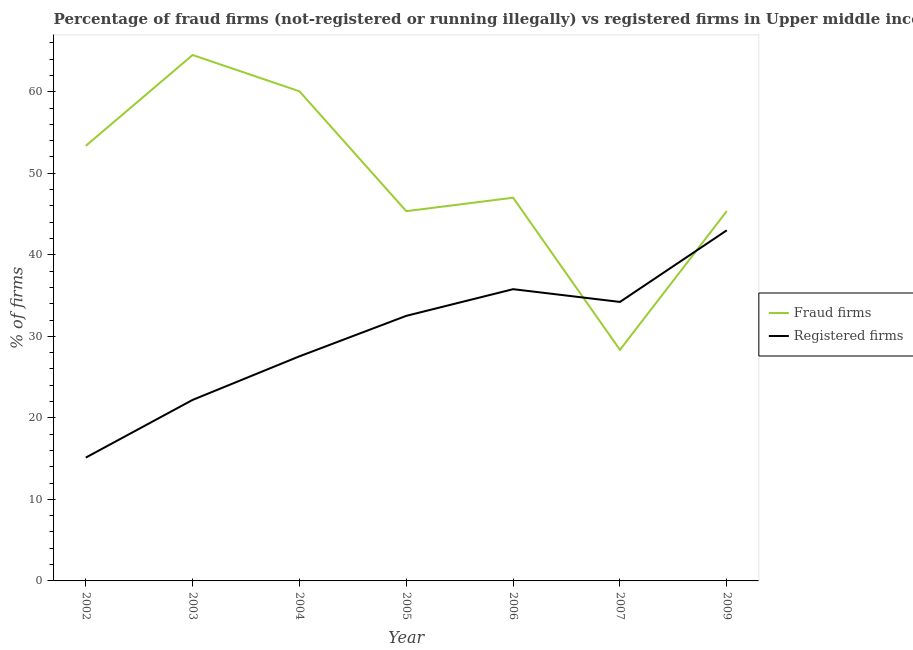How many different coloured lines are there?
Give a very brief answer. 2. Does the line corresponding to percentage of registered firms intersect with the line corresponding to percentage of fraud firms?
Keep it short and to the point. Yes. What is the percentage of fraud firms in 2002?
Make the answer very short. 53.35. Across all years, what is the minimum percentage of registered firms?
Make the answer very short. 15.12. In which year was the percentage of fraud firms maximum?
Your answer should be compact. 2003. What is the total percentage of registered firms in the graph?
Provide a short and direct response. 210.37. What is the difference between the percentage of registered firms in 2002 and that in 2007?
Ensure brevity in your answer.  -19.09. What is the difference between the percentage of registered firms in 2005 and the percentage of fraud firms in 2006?
Ensure brevity in your answer.  -14.49. What is the average percentage of registered firms per year?
Provide a succinct answer. 30.05. In the year 2003, what is the difference between the percentage of fraud firms and percentage of registered firms?
Make the answer very short. 42.3. In how many years, is the percentage of registered firms greater than 58 %?
Provide a succinct answer. 0. What is the ratio of the percentage of registered firms in 2004 to that in 2005?
Provide a short and direct response. 0.85. Is the percentage of registered firms in 2007 less than that in 2009?
Provide a short and direct response. Yes. Is the difference between the percentage of registered firms in 2003 and 2009 greater than the difference between the percentage of fraud firms in 2003 and 2009?
Your answer should be very brief. No. What is the difference between the highest and the second highest percentage of registered firms?
Ensure brevity in your answer.  7.22. What is the difference between the highest and the lowest percentage of registered firms?
Your answer should be compact. 27.88. In how many years, is the percentage of registered firms greater than the average percentage of registered firms taken over all years?
Ensure brevity in your answer.  4. Is the sum of the percentage of fraud firms in 2004 and 2005 greater than the maximum percentage of registered firms across all years?
Keep it short and to the point. Yes. Does the percentage of registered firms monotonically increase over the years?
Your answer should be very brief. No. How many years are there in the graph?
Make the answer very short. 7. Are the values on the major ticks of Y-axis written in scientific E-notation?
Offer a very short reply. No. Does the graph contain grids?
Keep it short and to the point. No. Where does the legend appear in the graph?
Your response must be concise. Center right. How many legend labels are there?
Make the answer very short. 2. How are the legend labels stacked?
Ensure brevity in your answer.  Vertical. What is the title of the graph?
Give a very brief answer. Percentage of fraud firms (not-registered or running illegally) vs registered firms in Upper middle income. Does "Register a property" appear as one of the legend labels in the graph?
Your response must be concise. No. What is the label or title of the X-axis?
Provide a succinct answer. Year. What is the label or title of the Y-axis?
Provide a short and direct response. % of firms. What is the % of firms in Fraud firms in 2002?
Offer a terse response. 53.35. What is the % of firms in Registered firms in 2002?
Make the answer very short. 15.12. What is the % of firms in Fraud firms in 2003?
Offer a very short reply. 64.5. What is the % of firms of Fraud firms in 2004?
Your response must be concise. 60.05. What is the % of firms in Registered firms in 2004?
Provide a short and direct response. 27.55. What is the % of firms of Fraud firms in 2005?
Your answer should be very brief. 45.35. What is the % of firms of Registered firms in 2005?
Your answer should be compact. 32.51. What is the % of firms of Fraud firms in 2006?
Keep it short and to the point. 47. What is the % of firms of Registered firms in 2006?
Keep it short and to the point. 35.78. What is the % of firms in Fraud firms in 2007?
Offer a terse response. 28.34. What is the % of firms of Registered firms in 2007?
Ensure brevity in your answer.  34.22. What is the % of firms of Fraud firms in 2009?
Give a very brief answer. 45.35. Across all years, what is the maximum % of firms in Fraud firms?
Make the answer very short. 64.5. Across all years, what is the maximum % of firms in Registered firms?
Make the answer very short. 43. Across all years, what is the minimum % of firms in Fraud firms?
Offer a very short reply. 28.34. Across all years, what is the minimum % of firms of Registered firms?
Your response must be concise. 15.12. What is the total % of firms of Fraud firms in the graph?
Offer a very short reply. 343.94. What is the total % of firms in Registered firms in the graph?
Keep it short and to the point. 210.37. What is the difference between the % of firms in Fraud firms in 2002 and that in 2003?
Your answer should be compact. -11.15. What is the difference between the % of firms of Registered firms in 2002 and that in 2003?
Provide a succinct answer. -7.08. What is the difference between the % of firms of Fraud firms in 2002 and that in 2004?
Your answer should be very brief. -6.7. What is the difference between the % of firms in Registered firms in 2002 and that in 2004?
Provide a short and direct response. -12.42. What is the difference between the % of firms in Fraud firms in 2002 and that in 2005?
Your response must be concise. 8.01. What is the difference between the % of firms in Registered firms in 2002 and that in 2005?
Your answer should be compact. -17.39. What is the difference between the % of firms in Fraud firms in 2002 and that in 2006?
Make the answer very short. 6.36. What is the difference between the % of firms in Registered firms in 2002 and that in 2006?
Your response must be concise. -20.66. What is the difference between the % of firms of Fraud firms in 2002 and that in 2007?
Ensure brevity in your answer.  25.01. What is the difference between the % of firms in Registered firms in 2002 and that in 2007?
Offer a terse response. -19.09. What is the difference between the % of firms of Fraud firms in 2002 and that in 2009?
Make the answer very short. 8. What is the difference between the % of firms in Registered firms in 2002 and that in 2009?
Ensure brevity in your answer.  -27.88. What is the difference between the % of firms in Fraud firms in 2003 and that in 2004?
Provide a short and direct response. 4.45. What is the difference between the % of firms of Registered firms in 2003 and that in 2004?
Provide a succinct answer. -5.35. What is the difference between the % of firms in Fraud firms in 2003 and that in 2005?
Provide a short and direct response. 19.15. What is the difference between the % of firms of Registered firms in 2003 and that in 2005?
Your response must be concise. -10.31. What is the difference between the % of firms in Fraud firms in 2003 and that in 2006?
Offer a terse response. 17.5. What is the difference between the % of firms in Registered firms in 2003 and that in 2006?
Your answer should be very brief. -13.58. What is the difference between the % of firms in Fraud firms in 2003 and that in 2007?
Provide a short and direct response. 36.16. What is the difference between the % of firms of Registered firms in 2003 and that in 2007?
Ensure brevity in your answer.  -12.02. What is the difference between the % of firms in Fraud firms in 2003 and that in 2009?
Your response must be concise. 19.15. What is the difference between the % of firms in Registered firms in 2003 and that in 2009?
Keep it short and to the point. -20.8. What is the difference between the % of firms in Fraud firms in 2004 and that in 2005?
Make the answer very short. 14.7. What is the difference between the % of firms in Registered firms in 2004 and that in 2005?
Give a very brief answer. -4.96. What is the difference between the % of firms of Fraud firms in 2004 and that in 2006?
Give a very brief answer. 13.05. What is the difference between the % of firms of Registered firms in 2004 and that in 2006?
Ensure brevity in your answer.  -8.23. What is the difference between the % of firms of Fraud firms in 2004 and that in 2007?
Give a very brief answer. 31.71. What is the difference between the % of firms in Registered firms in 2004 and that in 2007?
Ensure brevity in your answer.  -6.67. What is the difference between the % of firms in Fraud firms in 2004 and that in 2009?
Your answer should be very brief. 14.7. What is the difference between the % of firms of Registered firms in 2004 and that in 2009?
Make the answer very short. -15.45. What is the difference between the % of firms of Fraud firms in 2005 and that in 2006?
Your answer should be very brief. -1.65. What is the difference between the % of firms in Registered firms in 2005 and that in 2006?
Your answer should be compact. -3.27. What is the difference between the % of firms of Fraud firms in 2005 and that in 2007?
Your response must be concise. 17.01. What is the difference between the % of firms in Registered firms in 2005 and that in 2007?
Your response must be concise. -1.71. What is the difference between the % of firms in Fraud firms in 2005 and that in 2009?
Provide a succinct answer. -0.01. What is the difference between the % of firms of Registered firms in 2005 and that in 2009?
Provide a succinct answer. -10.49. What is the difference between the % of firms of Fraud firms in 2006 and that in 2007?
Your answer should be very brief. 18.66. What is the difference between the % of firms of Registered firms in 2006 and that in 2007?
Your answer should be very brief. 1.56. What is the difference between the % of firms of Fraud firms in 2006 and that in 2009?
Make the answer very short. 1.64. What is the difference between the % of firms in Registered firms in 2006 and that in 2009?
Offer a terse response. -7.22. What is the difference between the % of firms in Fraud firms in 2007 and that in 2009?
Your response must be concise. -17.01. What is the difference between the % of firms of Registered firms in 2007 and that in 2009?
Keep it short and to the point. -8.78. What is the difference between the % of firms in Fraud firms in 2002 and the % of firms in Registered firms in 2003?
Your answer should be compact. 31.15. What is the difference between the % of firms of Fraud firms in 2002 and the % of firms of Registered firms in 2004?
Keep it short and to the point. 25.81. What is the difference between the % of firms in Fraud firms in 2002 and the % of firms in Registered firms in 2005?
Your answer should be compact. 20.84. What is the difference between the % of firms of Fraud firms in 2002 and the % of firms of Registered firms in 2006?
Offer a terse response. 17.57. What is the difference between the % of firms in Fraud firms in 2002 and the % of firms in Registered firms in 2007?
Your response must be concise. 19.14. What is the difference between the % of firms of Fraud firms in 2002 and the % of firms of Registered firms in 2009?
Provide a succinct answer. 10.35. What is the difference between the % of firms in Fraud firms in 2003 and the % of firms in Registered firms in 2004?
Provide a short and direct response. 36.95. What is the difference between the % of firms in Fraud firms in 2003 and the % of firms in Registered firms in 2005?
Your answer should be compact. 31.99. What is the difference between the % of firms in Fraud firms in 2003 and the % of firms in Registered firms in 2006?
Provide a succinct answer. 28.72. What is the difference between the % of firms of Fraud firms in 2003 and the % of firms of Registered firms in 2007?
Your answer should be very brief. 30.28. What is the difference between the % of firms of Fraud firms in 2003 and the % of firms of Registered firms in 2009?
Offer a terse response. 21.5. What is the difference between the % of firms in Fraud firms in 2004 and the % of firms in Registered firms in 2005?
Your answer should be compact. 27.54. What is the difference between the % of firms of Fraud firms in 2004 and the % of firms of Registered firms in 2006?
Give a very brief answer. 24.27. What is the difference between the % of firms of Fraud firms in 2004 and the % of firms of Registered firms in 2007?
Keep it short and to the point. 25.83. What is the difference between the % of firms in Fraud firms in 2004 and the % of firms in Registered firms in 2009?
Ensure brevity in your answer.  17.05. What is the difference between the % of firms in Fraud firms in 2005 and the % of firms in Registered firms in 2006?
Your answer should be compact. 9.57. What is the difference between the % of firms of Fraud firms in 2005 and the % of firms of Registered firms in 2007?
Your answer should be very brief. 11.13. What is the difference between the % of firms of Fraud firms in 2005 and the % of firms of Registered firms in 2009?
Keep it short and to the point. 2.35. What is the difference between the % of firms of Fraud firms in 2006 and the % of firms of Registered firms in 2007?
Your answer should be compact. 12.78. What is the difference between the % of firms in Fraud firms in 2006 and the % of firms in Registered firms in 2009?
Keep it short and to the point. 4. What is the difference between the % of firms in Fraud firms in 2007 and the % of firms in Registered firms in 2009?
Make the answer very short. -14.66. What is the average % of firms in Fraud firms per year?
Provide a short and direct response. 49.13. What is the average % of firms in Registered firms per year?
Provide a short and direct response. 30.05. In the year 2002, what is the difference between the % of firms of Fraud firms and % of firms of Registered firms?
Provide a succinct answer. 38.23. In the year 2003, what is the difference between the % of firms in Fraud firms and % of firms in Registered firms?
Ensure brevity in your answer.  42.3. In the year 2004, what is the difference between the % of firms in Fraud firms and % of firms in Registered firms?
Make the answer very short. 32.5. In the year 2005, what is the difference between the % of firms of Fraud firms and % of firms of Registered firms?
Provide a succinct answer. 12.84. In the year 2006, what is the difference between the % of firms in Fraud firms and % of firms in Registered firms?
Provide a short and direct response. 11.22. In the year 2007, what is the difference between the % of firms of Fraud firms and % of firms of Registered firms?
Your response must be concise. -5.88. In the year 2009, what is the difference between the % of firms in Fraud firms and % of firms in Registered firms?
Keep it short and to the point. 2.35. What is the ratio of the % of firms of Fraud firms in 2002 to that in 2003?
Make the answer very short. 0.83. What is the ratio of the % of firms of Registered firms in 2002 to that in 2003?
Offer a very short reply. 0.68. What is the ratio of the % of firms in Fraud firms in 2002 to that in 2004?
Keep it short and to the point. 0.89. What is the ratio of the % of firms of Registered firms in 2002 to that in 2004?
Your response must be concise. 0.55. What is the ratio of the % of firms in Fraud firms in 2002 to that in 2005?
Make the answer very short. 1.18. What is the ratio of the % of firms of Registered firms in 2002 to that in 2005?
Offer a very short reply. 0.47. What is the ratio of the % of firms in Fraud firms in 2002 to that in 2006?
Give a very brief answer. 1.14. What is the ratio of the % of firms in Registered firms in 2002 to that in 2006?
Give a very brief answer. 0.42. What is the ratio of the % of firms in Fraud firms in 2002 to that in 2007?
Provide a short and direct response. 1.88. What is the ratio of the % of firms in Registered firms in 2002 to that in 2007?
Offer a terse response. 0.44. What is the ratio of the % of firms in Fraud firms in 2002 to that in 2009?
Provide a short and direct response. 1.18. What is the ratio of the % of firms in Registered firms in 2002 to that in 2009?
Ensure brevity in your answer.  0.35. What is the ratio of the % of firms of Fraud firms in 2003 to that in 2004?
Your answer should be very brief. 1.07. What is the ratio of the % of firms in Registered firms in 2003 to that in 2004?
Provide a short and direct response. 0.81. What is the ratio of the % of firms in Fraud firms in 2003 to that in 2005?
Offer a terse response. 1.42. What is the ratio of the % of firms in Registered firms in 2003 to that in 2005?
Your answer should be very brief. 0.68. What is the ratio of the % of firms of Fraud firms in 2003 to that in 2006?
Your answer should be very brief. 1.37. What is the ratio of the % of firms of Registered firms in 2003 to that in 2006?
Offer a terse response. 0.62. What is the ratio of the % of firms in Fraud firms in 2003 to that in 2007?
Your response must be concise. 2.28. What is the ratio of the % of firms of Registered firms in 2003 to that in 2007?
Ensure brevity in your answer.  0.65. What is the ratio of the % of firms of Fraud firms in 2003 to that in 2009?
Keep it short and to the point. 1.42. What is the ratio of the % of firms of Registered firms in 2003 to that in 2009?
Give a very brief answer. 0.52. What is the ratio of the % of firms in Fraud firms in 2004 to that in 2005?
Offer a very short reply. 1.32. What is the ratio of the % of firms in Registered firms in 2004 to that in 2005?
Offer a terse response. 0.85. What is the ratio of the % of firms of Fraud firms in 2004 to that in 2006?
Give a very brief answer. 1.28. What is the ratio of the % of firms of Registered firms in 2004 to that in 2006?
Provide a succinct answer. 0.77. What is the ratio of the % of firms in Fraud firms in 2004 to that in 2007?
Your answer should be compact. 2.12. What is the ratio of the % of firms of Registered firms in 2004 to that in 2007?
Offer a terse response. 0.81. What is the ratio of the % of firms in Fraud firms in 2004 to that in 2009?
Provide a succinct answer. 1.32. What is the ratio of the % of firms of Registered firms in 2004 to that in 2009?
Your response must be concise. 0.64. What is the ratio of the % of firms in Fraud firms in 2005 to that in 2006?
Offer a very short reply. 0.96. What is the ratio of the % of firms of Registered firms in 2005 to that in 2006?
Your response must be concise. 0.91. What is the ratio of the % of firms in Fraud firms in 2005 to that in 2007?
Ensure brevity in your answer.  1.6. What is the ratio of the % of firms of Registered firms in 2005 to that in 2007?
Offer a very short reply. 0.95. What is the ratio of the % of firms of Fraud firms in 2005 to that in 2009?
Provide a short and direct response. 1. What is the ratio of the % of firms in Registered firms in 2005 to that in 2009?
Keep it short and to the point. 0.76. What is the ratio of the % of firms in Fraud firms in 2006 to that in 2007?
Make the answer very short. 1.66. What is the ratio of the % of firms of Registered firms in 2006 to that in 2007?
Offer a terse response. 1.05. What is the ratio of the % of firms in Fraud firms in 2006 to that in 2009?
Your answer should be very brief. 1.04. What is the ratio of the % of firms in Registered firms in 2006 to that in 2009?
Your answer should be compact. 0.83. What is the ratio of the % of firms in Fraud firms in 2007 to that in 2009?
Your response must be concise. 0.62. What is the ratio of the % of firms of Registered firms in 2007 to that in 2009?
Offer a very short reply. 0.8. What is the difference between the highest and the second highest % of firms in Fraud firms?
Provide a succinct answer. 4.45. What is the difference between the highest and the second highest % of firms of Registered firms?
Provide a short and direct response. 7.22. What is the difference between the highest and the lowest % of firms of Fraud firms?
Your answer should be very brief. 36.16. What is the difference between the highest and the lowest % of firms of Registered firms?
Give a very brief answer. 27.88. 